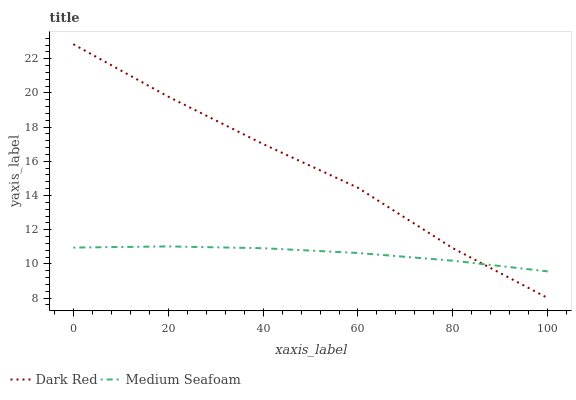Does Medium Seafoam have the minimum area under the curve?
Answer yes or no. Yes. Does Dark Red have the maximum area under the curve?
Answer yes or no. Yes. Does Medium Seafoam have the maximum area under the curve?
Answer yes or no. No. Is Medium Seafoam the smoothest?
Answer yes or no. Yes. Is Dark Red the roughest?
Answer yes or no. Yes. Is Medium Seafoam the roughest?
Answer yes or no. No. Does Dark Red have the lowest value?
Answer yes or no. Yes. Does Medium Seafoam have the lowest value?
Answer yes or no. No. Does Dark Red have the highest value?
Answer yes or no. Yes. Does Medium Seafoam have the highest value?
Answer yes or no. No. Does Dark Red intersect Medium Seafoam?
Answer yes or no. Yes. Is Dark Red less than Medium Seafoam?
Answer yes or no. No. Is Dark Red greater than Medium Seafoam?
Answer yes or no. No. 